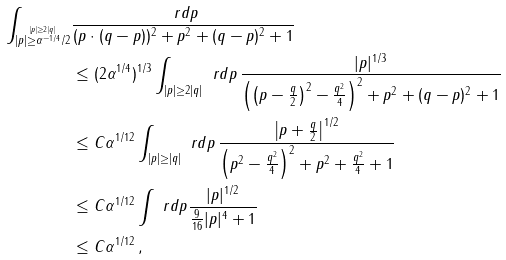<formula> <loc_0><loc_0><loc_500><loc_500>\int _ { \stackrel { | p | \geq 2 | q | } { | p | \geq \alpha ^ { - 1 / 4 } / 2 } } & \frac { \ r d p } { ( p \cdot ( q - p ) ) ^ { 2 } + p ^ { 2 } + ( q - p ) ^ { 2 } + 1 } \\ & \leq ( 2 \alpha ^ { 1 / 4 } ) ^ { 1 / 3 } \int _ { | p | \geq 2 | q | } \ r d p \, \frac { | p | ^ { 1 / 3 } } { \left ( \left ( p - \frac { q } { 2 } \right ) ^ { 2 } - \frac { q ^ { 2 } } { 4 } \right ) ^ { 2 } + p ^ { 2 } + ( q - p ) ^ { 2 } + 1 } \\ & \leq C \alpha ^ { 1 / 1 2 } \int _ { | p | \geq | q | } \ r d p \, \frac { \left | p + \frac { q } { 2 } \right | ^ { 1 / 2 } } { \left ( p ^ { 2 } - \frac { q ^ { 2 } } { 4 } \right ) ^ { 2 } + p ^ { 2 } + \frac { q ^ { 2 } } { 4 } + 1 } \\ & \leq C \alpha ^ { 1 / 1 2 } \int \ r d p \frac { | p | ^ { 1 / 2 } } { \frac { 9 } { 1 6 } | p | ^ { 4 } + 1 } \\ & \leq C \alpha ^ { 1 / 1 2 } \, ,</formula> 